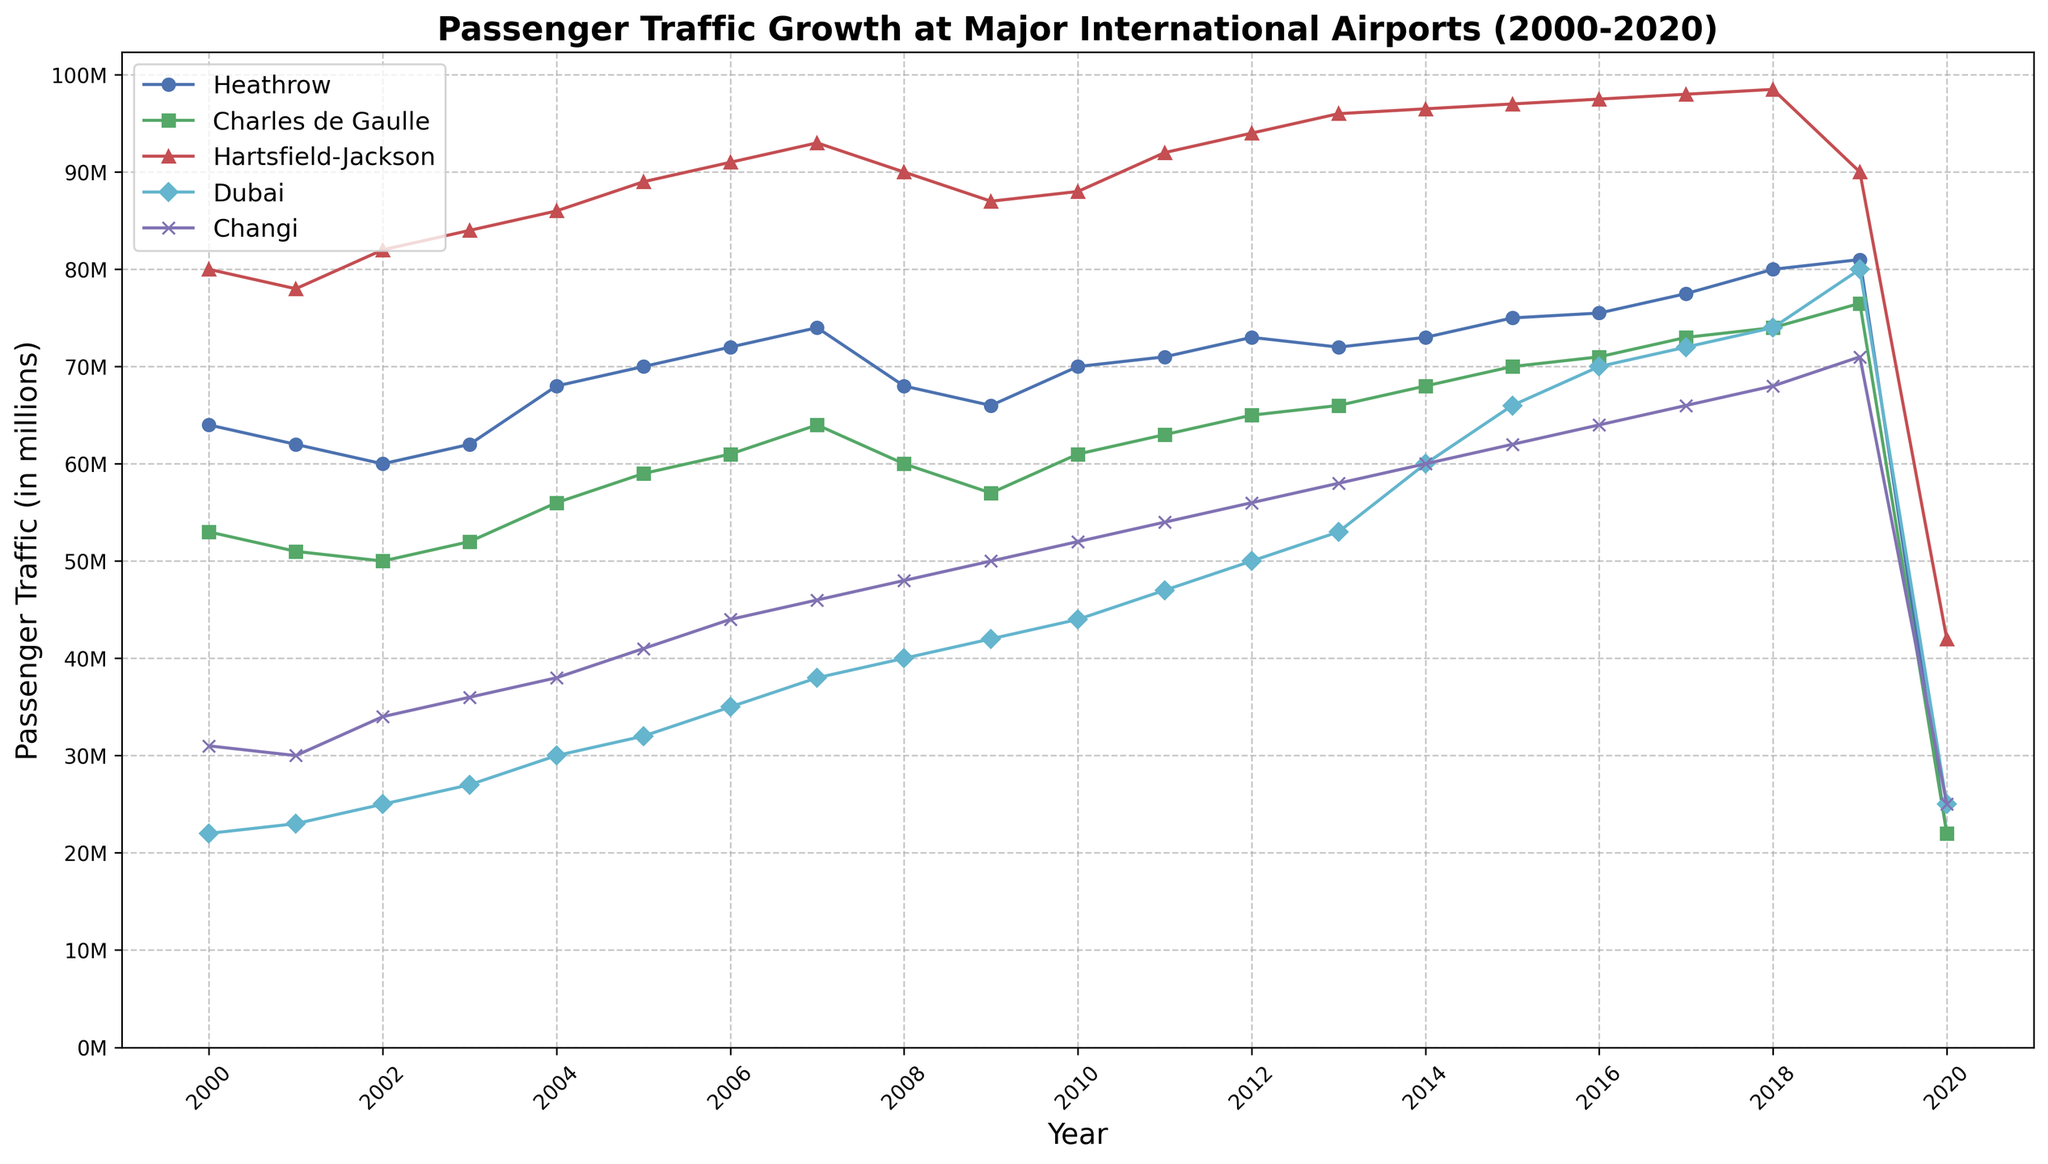What was the passenger traffic at Dubai in 2018? Look at the line corresponding to Dubai and trace it to the year 2018 on the x-axis. The value is 74 million.
Answer: 74 million Which airport had the highest passenger traffic in 2010? Compare the points of each airport's line for the year 2010. Hartsfield-Jackson had 88 million, which is the highest.
Answer: Hartsfield-Jackson What is the difference in passenger traffic between Heathrow and Changi in 2005? Find the values for Heathrow (70 million) and Changi (41 million) in 2005. Subtract Changi's from Heathrow's value: 70 - 41 = 29 million.
Answer: 29 million Which airport experienced the highest growth in passenger traffic from 2000 to 2019? Calculate the difference in passenger traffic for each airport from 2000 to 2019. Dubai: 80 - 22 = 58 million. Dubai has the highest growth.
Answer: Dubai What was the passenger traffic decline at Charles de Gaulle from 2019 to 2020? Subtract the 2020 value (22 million) from the 2019 value (76.5 million). 76.5 - 22 = 54.5 million decline.
Answer: 54.5 million When did Changi's passenger traffic first exceed 50 million? Trace Changi's line and identify the first year the y-value exceeds 50 million. This occurs in 2010 (52 million).
Answer: 2010 Between 2003 and 2014, which airport had the most consistent growth in passenger traffic? Visually check for the smoothest, linear growth among the lines. Changi shows the most consistent growth with a steady increase.
Answer: Changi Which airports saw a decline in traffic from 2019 to 2020? Compare 2019 and 2020 values for all airports. All airports saw a decline: Heathrow (81 to 22 million), Charles de Gaulle (76.5 to 22 million), Hartsfield-Jackson (90 to 42 million), Dubai (80 to 25 million), and Changi (71 to 25 million).
Answer: All airports What’s the average passenger traffic at Heathrow over the years 2000-2020? Sum all yearly passenger values for Heathrow from 2000 to 2020 and divide by 21 (number of years). Total is 75.75 million, 75,750,000/21 = approximately 3.607 million.
Answer: approximately 3.607 million 